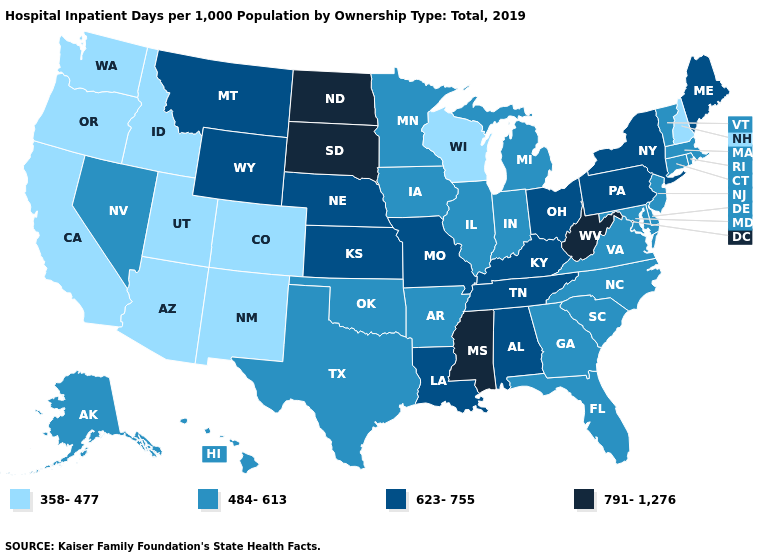Does Louisiana have a higher value than Hawaii?
Answer briefly. Yes. Name the states that have a value in the range 791-1,276?
Quick response, please. Mississippi, North Dakota, South Dakota, West Virginia. Which states have the highest value in the USA?
Write a very short answer. Mississippi, North Dakota, South Dakota, West Virginia. Name the states that have a value in the range 484-613?
Quick response, please. Alaska, Arkansas, Connecticut, Delaware, Florida, Georgia, Hawaii, Illinois, Indiana, Iowa, Maryland, Massachusetts, Michigan, Minnesota, Nevada, New Jersey, North Carolina, Oklahoma, Rhode Island, South Carolina, Texas, Vermont, Virginia. Name the states that have a value in the range 623-755?
Be succinct. Alabama, Kansas, Kentucky, Louisiana, Maine, Missouri, Montana, Nebraska, New York, Ohio, Pennsylvania, Tennessee, Wyoming. What is the lowest value in states that border Georgia?
Keep it brief. 484-613. What is the value of Kentucky?
Concise answer only. 623-755. What is the highest value in states that border Minnesota?
Answer briefly. 791-1,276. Name the states that have a value in the range 484-613?
Keep it brief. Alaska, Arkansas, Connecticut, Delaware, Florida, Georgia, Hawaii, Illinois, Indiana, Iowa, Maryland, Massachusetts, Michigan, Minnesota, Nevada, New Jersey, North Carolina, Oklahoma, Rhode Island, South Carolina, Texas, Vermont, Virginia. What is the lowest value in states that border Tennessee?
Be succinct. 484-613. Which states have the highest value in the USA?
Quick response, please. Mississippi, North Dakota, South Dakota, West Virginia. Does the map have missing data?
Give a very brief answer. No. Name the states that have a value in the range 484-613?
Give a very brief answer. Alaska, Arkansas, Connecticut, Delaware, Florida, Georgia, Hawaii, Illinois, Indiana, Iowa, Maryland, Massachusetts, Michigan, Minnesota, Nevada, New Jersey, North Carolina, Oklahoma, Rhode Island, South Carolina, Texas, Vermont, Virginia. What is the value of Utah?
Give a very brief answer. 358-477. What is the value of Nevada?
Write a very short answer. 484-613. 